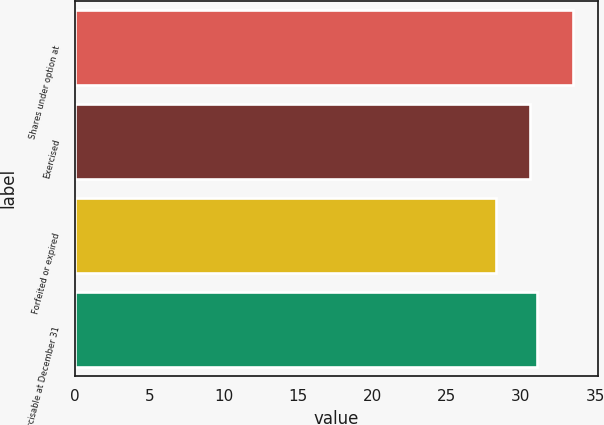Convert chart to OTSL. <chart><loc_0><loc_0><loc_500><loc_500><bar_chart><fcel>Shares under option at<fcel>Exercised<fcel>Forfeited or expired<fcel>Exercisable at December 31<nl><fcel>33.52<fcel>30.61<fcel>28.33<fcel>31.1<nl></chart> 